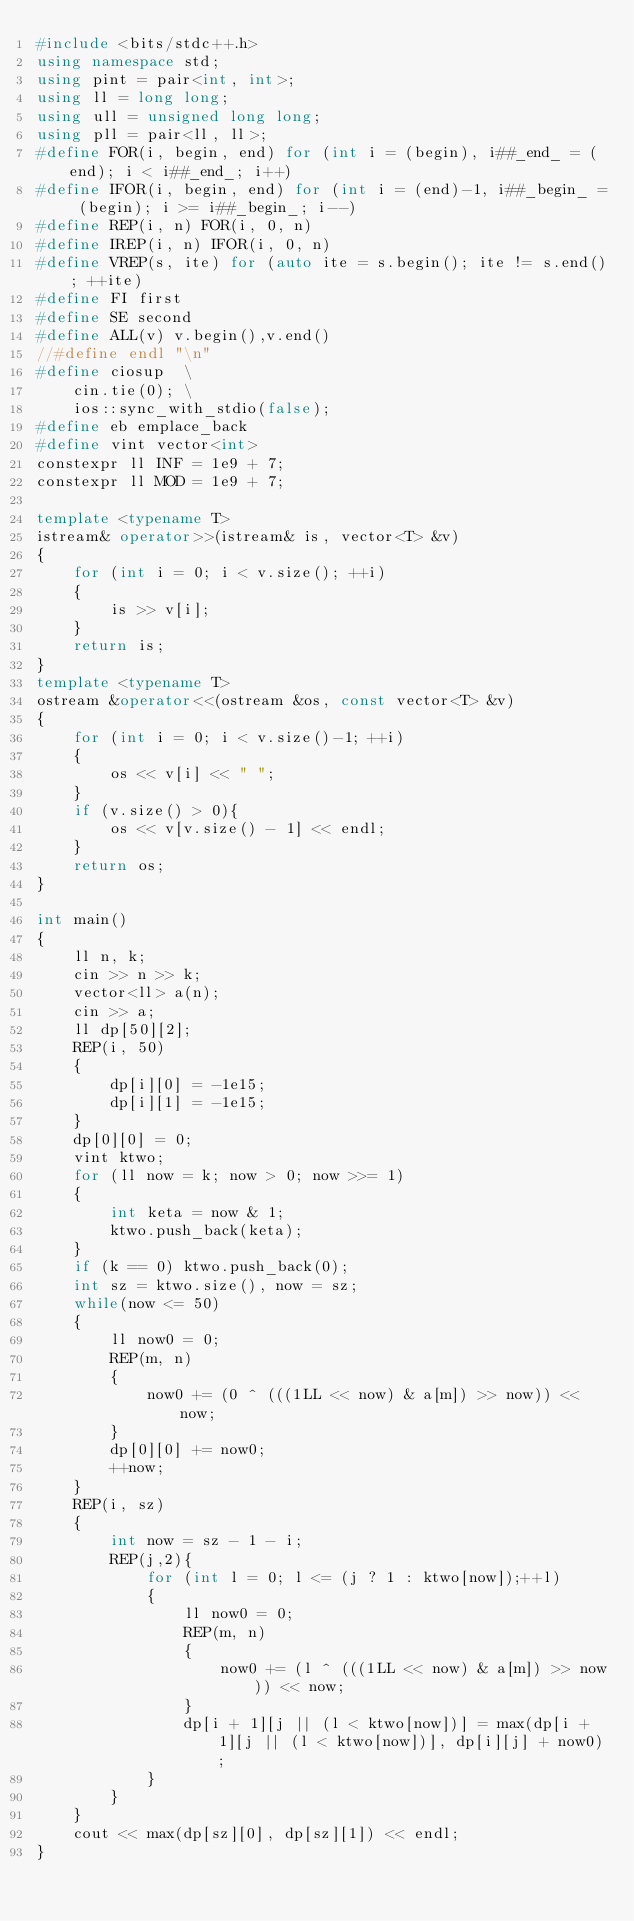Convert code to text. <code><loc_0><loc_0><loc_500><loc_500><_C++_>#include <bits/stdc++.h>
using namespace std;
using pint = pair<int, int>;
using ll = long long;
using ull = unsigned long long;
using pll = pair<ll, ll>;
#define FOR(i, begin, end) for (int i = (begin), i##_end_ = (end); i < i##_end_; i++)
#define IFOR(i, begin, end) for (int i = (end)-1, i##_begin_ = (begin); i >= i##_begin_; i--)
#define REP(i, n) FOR(i, 0, n)
#define IREP(i, n) IFOR(i, 0, n)
#define VREP(s, ite) for (auto ite = s.begin(); ite != s.end(); ++ite)
#define FI first
#define SE second
#define ALL(v) v.begin(),v.end()
//#define endl "\n"
#define ciosup  \
    cin.tie(0); \
    ios::sync_with_stdio(false);
#define eb emplace_back
#define vint vector<int>
constexpr ll INF = 1e9 + 7;
constexpr ll MOD = 1e9 + 7;

template <typename T>
istream& operator>>(istream& is, vector<T> &v)
{
    for (int i = 0; i < v.size(); ++i)
    {
        is >> v[i];
    }
    return is;
}
template <typename T>
ostream &operator<<(ostream &os, const vector<T> &v)
{
    for (int i = 0; i < v.size()-1; ++i)
    {
        os << v[i] << " ";
    }
    if (v.size() > 0){
        os << v[v.size() - 1] << endl;
    }
    return os;
}

int main()
{
    ll n, k;
    cin >> n >> k;
    vector<ll> a(n);
    cin >> a;
    ll dp[50][2];
    REP(i, 50)
    {
        dp[i][0] = -1e15;
        dp[i][1] = -1e15;
    }
    dp[0][0] = 0;
    vint ktwo;
    for (ll now = k; now > 0; now >>= 1)
    {
        int keta = now & 1;
        ktwo.push_back(keta);
    }
    if (k == 0) ktwo.push_back(0);
    int sz = ktwo.size(), now = sz;
    while(now <= 50)
    {
        ll now0 = 0;
        REP(m, n)
        {
            now0 += (0 ^ (((1LL << now) & a[m]) >> now)) << now;
        }
        dp[0][0] += now0;
        ++now;
    }
    REP(i, sz)
    {
        int now = sz - 1 - i;
        REP(j,2){
            for (int l = 0; l <= (j ? 1 : ktwo[now]);++l)
            {
                ll now0 = 0;
                REP(m, n)
                {
                    now0 += (l ^ (((1LL << now) & a[m]) >> now)) << now;
                }
                dp[i + 1][j || (l < ktwo[now])] = max(dp[i + 1][j || (l < ktwo[now])], dp[i][j] + now0);
            }
        }
    }
    cout << max(dp[sz][0], dp[sz][1]) << endl;
}</code> 